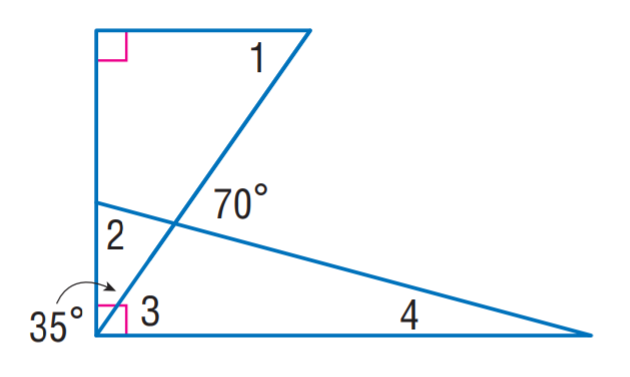Question: Find m \angle 2.
Choices:
A. 15
B. 55
C. 70
D. 75
Answer with the letter. Answer: D Question: Find m \angle 3.
Choices:
A. 15
B. 35
C. 55
D. 75
Answer with the letter. Answer: C Question: Find m \angle 1.
Choices:
A. 15
B. 35
C. 55
D. 70
Answer with the letter. Answer: C Question: Find m \angle 4.
Choices:
A. 10
B. 15
C. 35
D. 55
Answer with the letter. Answer: B 